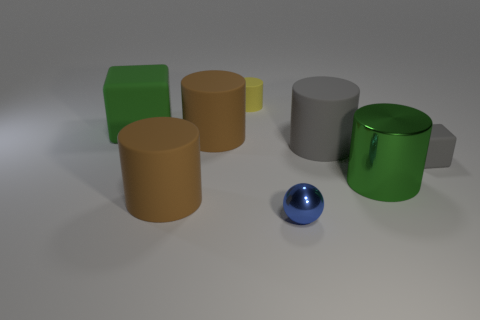There is a large shiny cylinder behind the brown thing in front of the small matte object that is right of the sphere; what is its color?
Make the answer very short. Green. Are the tiny object that is behind the large block and the large green cylinder made of the same material?
Your answer should be very brief. No. How many other things are there of the same material as the tiny gray block?
Offer a terse response. 5. There is a cube that is the same size as the gray cylinder; what is its material?
Your answer should be compact. Rubber. There is a brown thing in front of the green cylinder; does it have the same shape as the tiny rubber object to the right of the blue object?
Your answer should be compact. No. The gray object that is the same size as the green metallic thing is what shape?
Your response must be concise. Cylinder. Are the small object that is to the right of the tiny shiny sphere and the block on the left side of the big gray thing made of the same material?
Offer a very short reply. Yes. There is a small matte thing that is in front of the green matte object; are there any large blocks that are on the left side of it?
Make the answer very short. Yes. What color is the tiny cylinder that is made of the same material as the green block?
Offer a terse response. Yellow. Are there more green shiny things than large red objects?
Make the answer very short. Yes. 